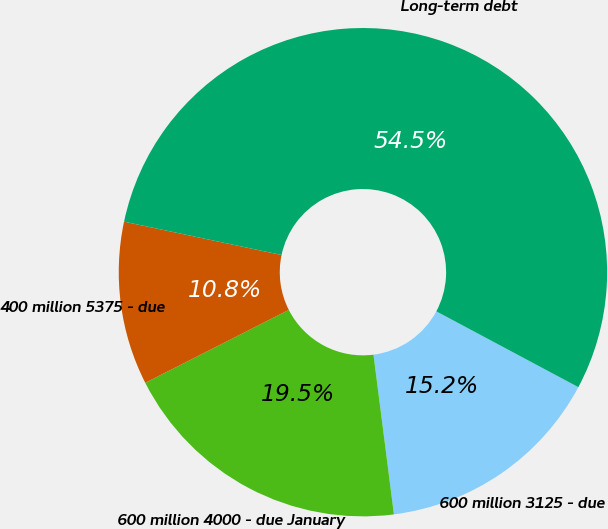Convert chart to OTSL. <chart><loc_0><loc_0><loc_500><loc_500><pie_chart><fcel>600 million 3125 - due<fcel>600 million 4000 - due January<fcel>400 million 5375 - due<fcel>Long-term debt<nl><fcel>15.17%<fcel>19.54%<fcel>10.8%<fcel>54.48%<nl></chart> 